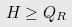<formula> <loc_0><loc_0><loc_500><loc_500>H \geq Q _ { R }</formula> 